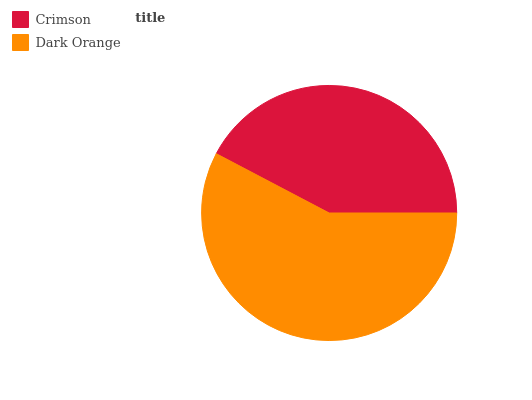Is Crimson the minimum?
Answer yes or no. Yes. Is Dark Orange the maximum?
Answer yes or no. Yes. Is Dark Orange the minimum?
Answer yes or no. No. Is Dark Orange greater than Crimson?
Answer yes or no. Yes. Is Crimson less than Dark Orange?
Answer yes or no. Yes. Is Crimson greater than Dark Orange?
Answer yes or no. No. Is Dark Orange less than Crimson?
Answer yes or no. No. Is Dark Orange the high median?
Answer yes or no. Yes. Is Crimson the low median?
Answer yes or no. Yes. Is Crimson the high median?
Answer yes or no. No. Is Dark Orange the low median?
Answer yes or no. No. 